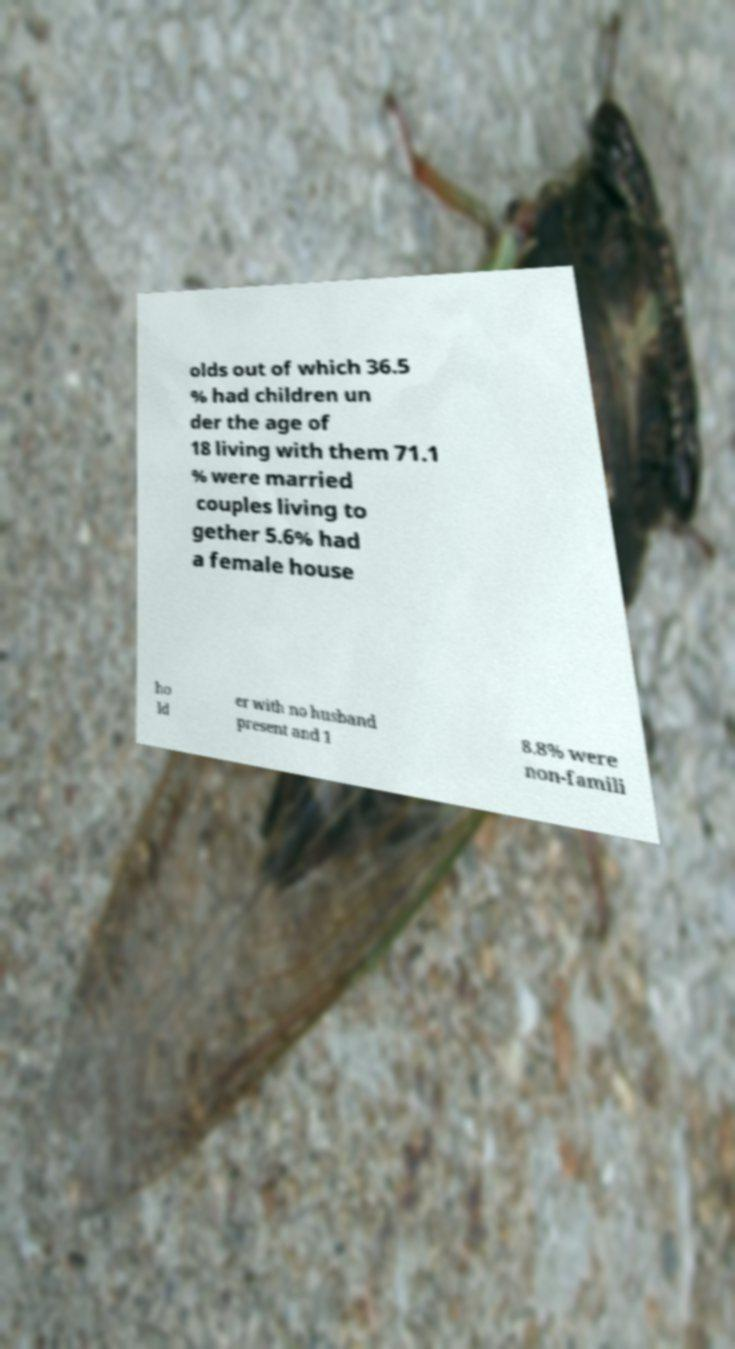Could you assist in decoding the text presented in this image and type it out clearly? olds out of which 36.5 % had children un der the age of 18 living with them 71.1 % were married couples living to gether 5.6% had a female house ho ld er with no husband present and 1 8.8% were non-famili 